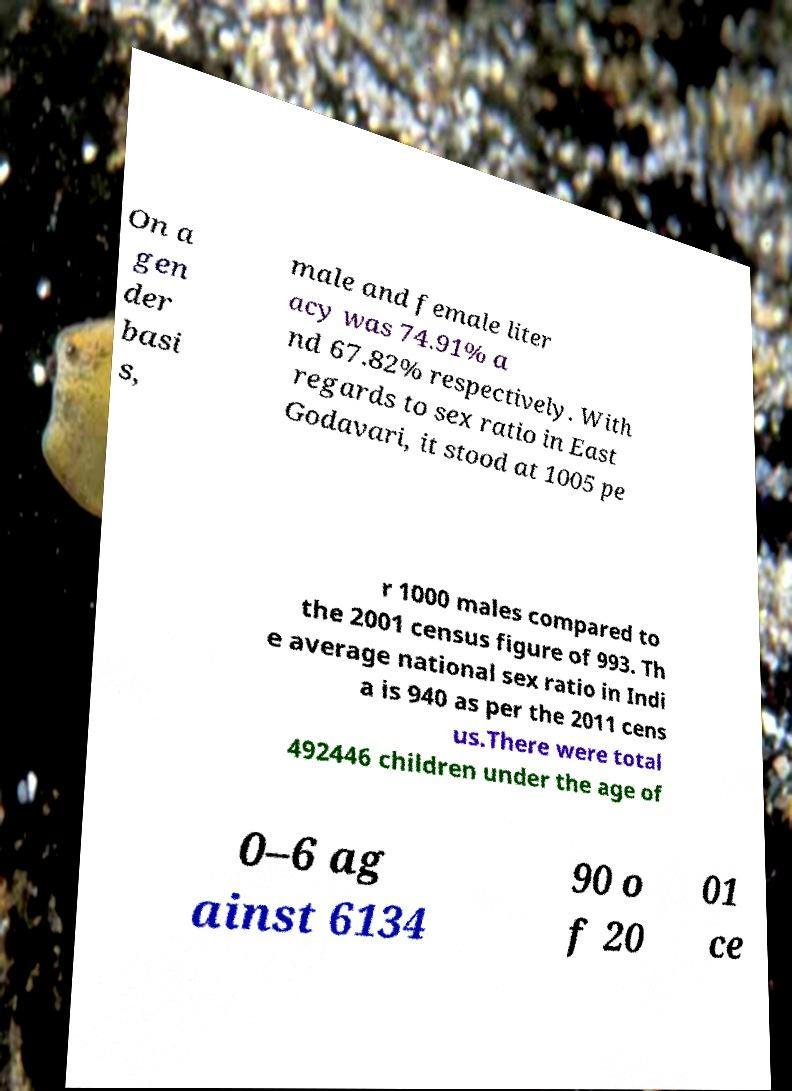Could you extract and type out the text from this image? On a gen der basi s, male and female liter acy was 74.91% a nd 67.82% respectively. With regards to sex ratio in East Godavari, it stood at 1005 pe r 1000 males compared to the 2001 census figure of 993. Th e average national sex ratio in Indi a is 940 as per the 2011 cens us.There were total 492446 children under the age of 0–6 ag ainst 6134 90 o f 20 01 ce 